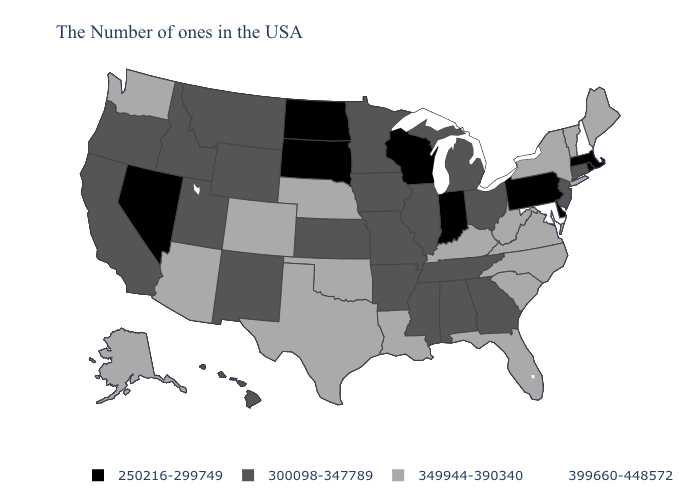What is the value of Tennessee?
Short answer required. 300098-347789. Which states have the lowest value in the South?
Keep it brief. Delaware. What is the value of Tennessee?
Quick response, please. 300098-347789. Does West Virginia have a lower value than New Hampshire?
Quick response, please. Yes. Which states have the highest value in the USA?
Concise answer only. New Hampshire, Maryland. Name the states that have a value in the range 399660-448572?
Give a very brief answer. New Hampshire, Maryland. Name the states that have a value in the range 349944-390340?
Concise answer only. Maine, Vermont, New York, Virginia, North Carolina, South Carolina, West Virginia, Florida, Kentucky, Louisiana, Nebraska, Oklahoma, Texas, Colorado, Arizona, Washington, Alaska. What is the highest value in the USA?
Be succinct. 399660-448572. Does the first symbol in the legend represent the smallest category?
Keep it brief. Yes. Which states have the lowest value in the USA?
Short answer required. Massachusetts, Rhode Island, Delaware, Pennsylvania, Indiana, Wisconsin, South Dakota, North Dakota, Nevada. What is the value of Oregon?
Be succinct. 300098-347789. Among the states that border Minnesota , does South Dakota have the highest value?
Write a very short answer. No. Among the states that border Louisiana , which have the highest value?
Answer briefly. Texas. What is the highest value in states that border Maine?
Be succinct. 399660-448572. 